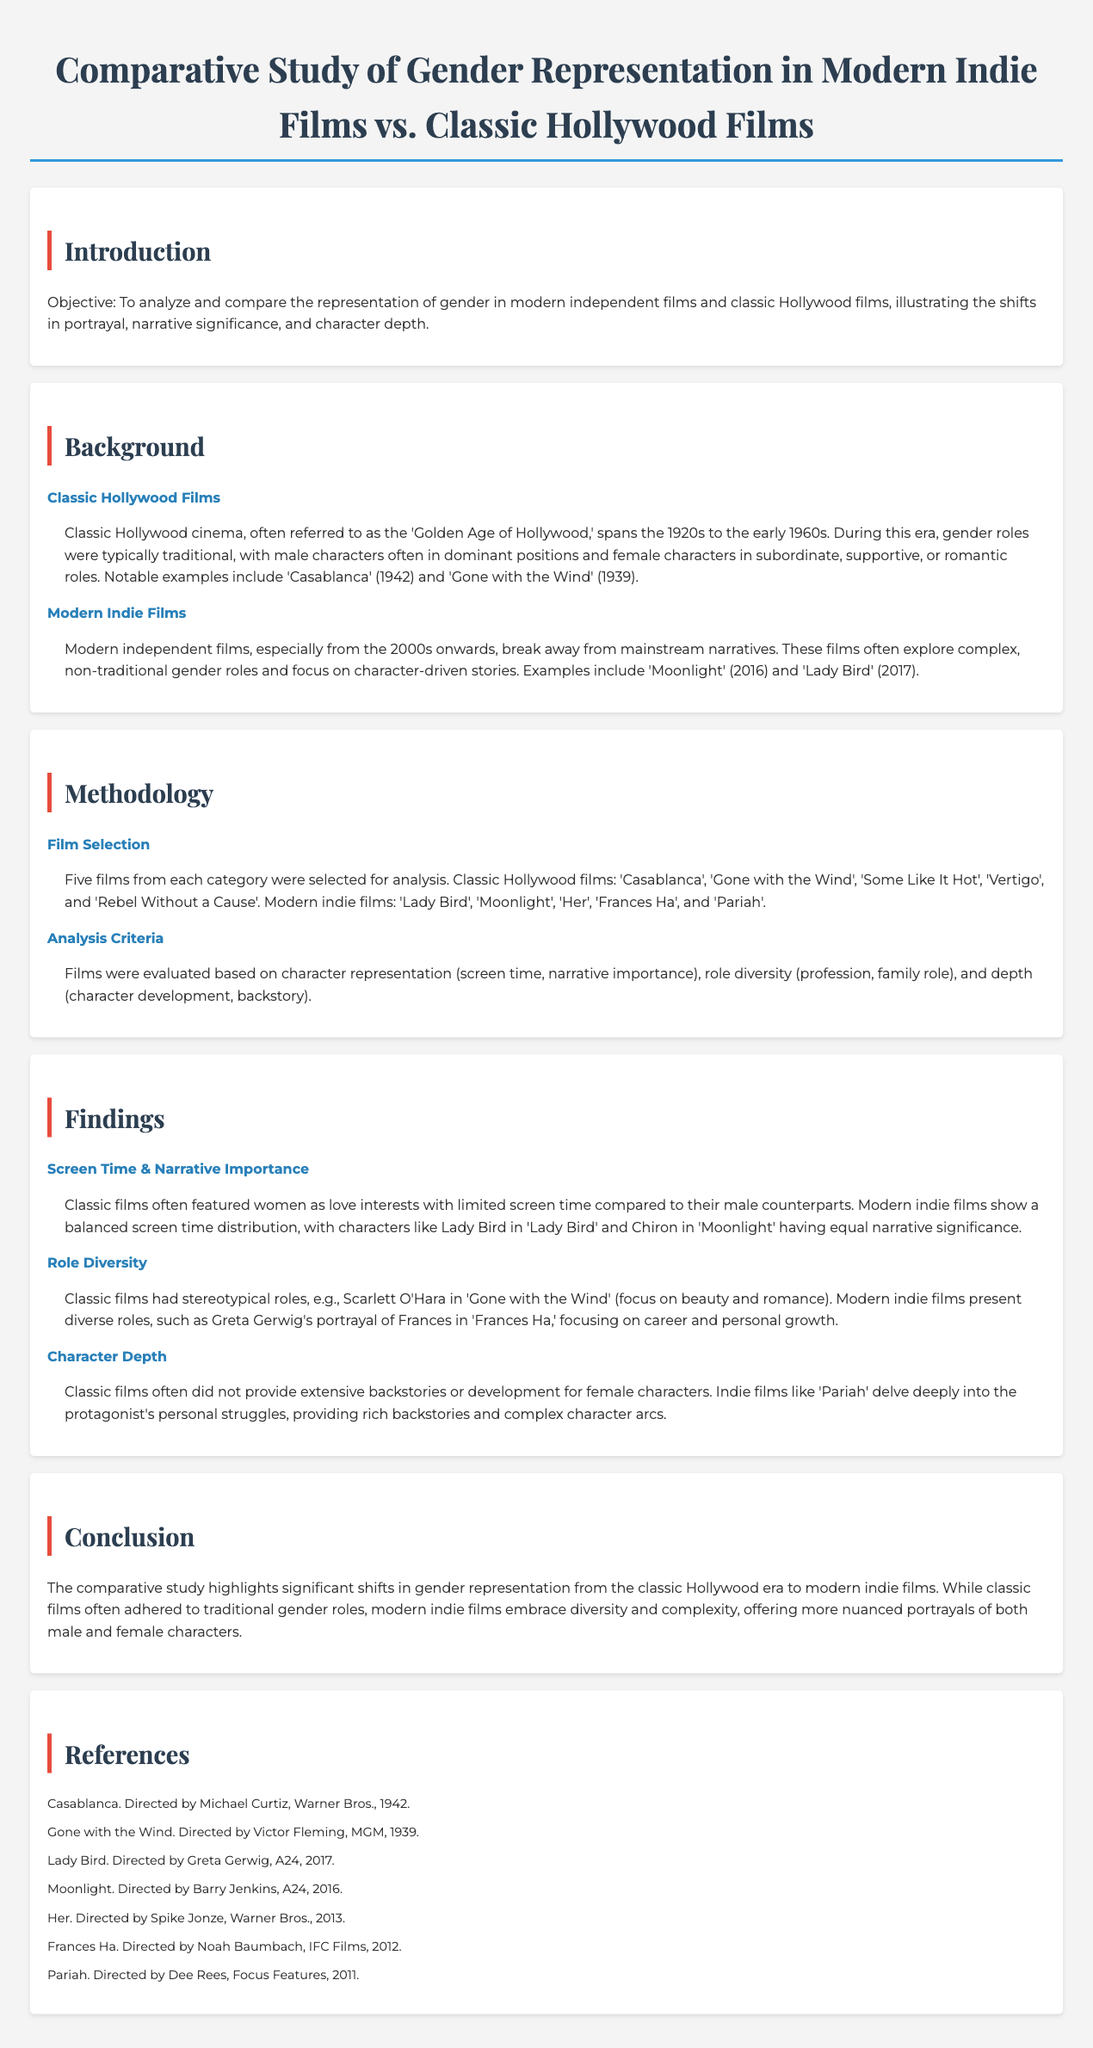What is the objective of the study? The objective is to analyze and compare the representation of gender in modern independent films and classic Hollywood films.
Answer: Analyze and compare gender representation What years does classic Hollywood cinema span? Classic Hollywood cinema is referred to as the 'Golden Age of Hollywood,' spanning from the 1920s to the early 1960s.
Answer: 1920s to early 1960s Name one classic Hollywood film mentioned in the report. One of the classic Hollywood films mentioned is 'Casablanca'.
Answer: Casablanca How many films were selected for analysis? Five films from each category were selected for analysis in the study.
Answer: Five What key feature distinguishes modern indie films according to the findings? Modern indie films show a balanced screen time distribution among characters.
Answer: Balanced screen time distribution What role did Scarlett O'Hara represent in 'Gone with the Wind'? Scarlett O'Hara was a character focused on beauty and romance according to the findings.
Answer: Beauty and romance Which film is cited as an example of character depth? 'Pariah' is cited as an example where the protagonist’s personal struggles are explored in-depth.
Answer: Pariah What is a key finding regarding character representation in classic films? Classic films often featured women as love interests with limited screen time compared to male counterparts.
Answer: Limited screen time What does the conclusion of the study highlight about gender representation shifts? The conclusion highlights significant shifts in gender representation from classic Hollywood to modern indie films.
Answer: Significant shifts in gender representation 